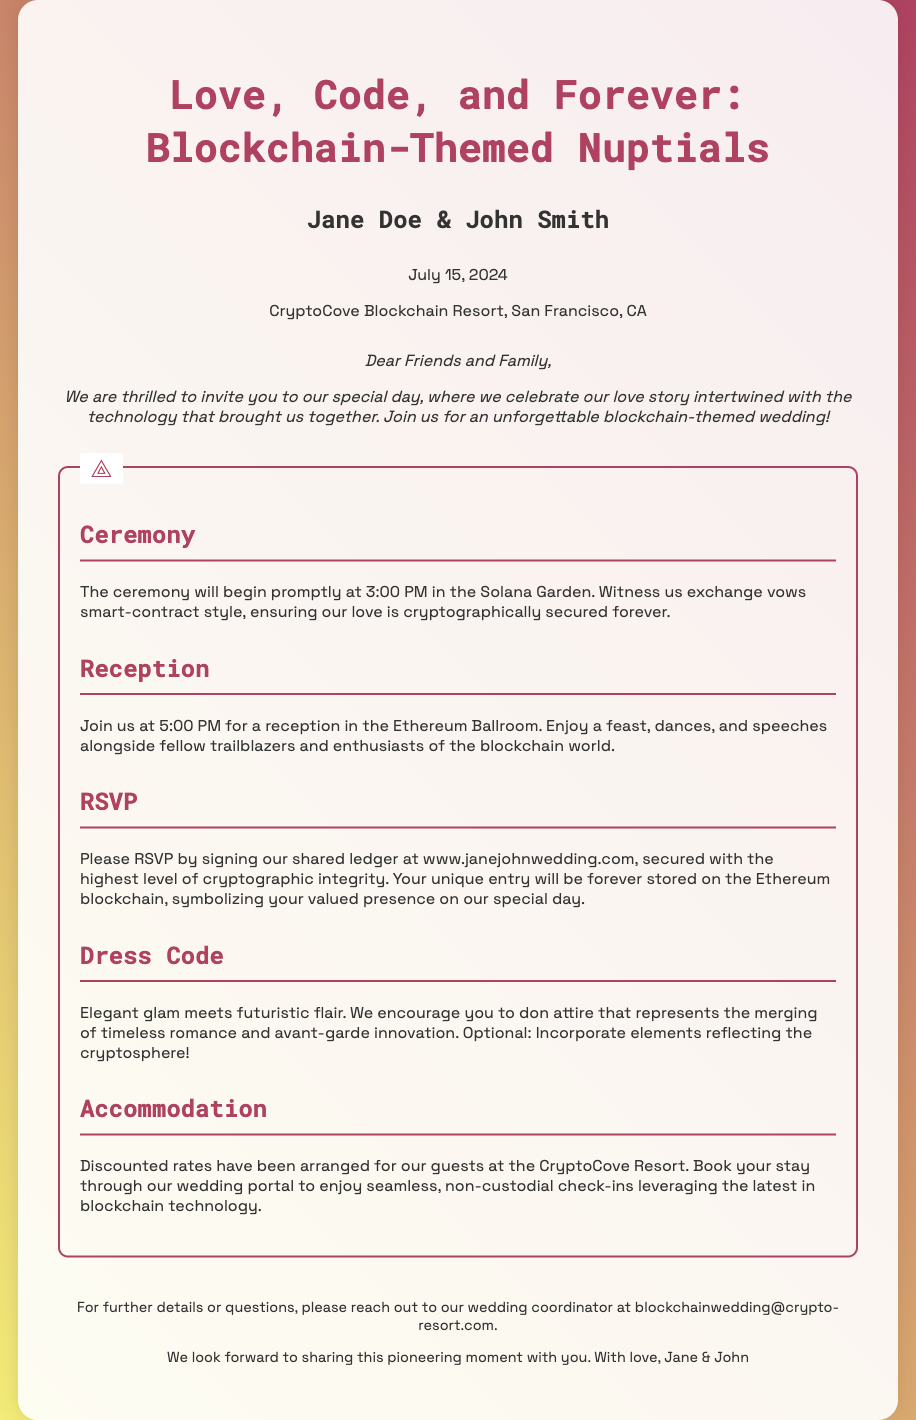What are the names of the couple? The names of the couple are explicitly mentioned in the header section under the title of the invitation.
Answer: Jane Doe & John Smith What is the date of the wedding? The wedding date is provided directly after the names in the header section of the invitation.
Answer: July 15, 2024 Where will the ceremony take place? The location of the ceremony is described in the ceremony section of the document.
Answer: Solana Garden What time does the reception start? The reception starting time is mentioned in the reception section of the invitation.
Answer: 5:00 PM What is requested in the RSVP section? The RSVP section outlines how guests should confirm their attendance at the wedding.
Answer: Signing our shared ledger What dress code is suggested? The dress code is articulated in the respective section of the invitation, merging different styles.
Answer: Elegant glam meets futuristic flair How will accommodation be managed for guests? The accommodation section describes how guests can book their stay for the wedding.
Answer: Discounted rates at CryptoCove Resort What technology is mentioned in relation to the reception? The technology mentioned in the context of RSVP indicates the document's unique theme intertwining love and technology.
Answer: Ethereum blockchain What kind of vows will be exchanged during the ceremony? The ceremony section specifies a creative twist on the traditional ceremony.
Answer: Smart-contract style What email can guests use for inquiries? The contact email for the wedding coordinator is provided in the footer of the invitation.
Answer: blockchainwedding@crypto-resort.com 